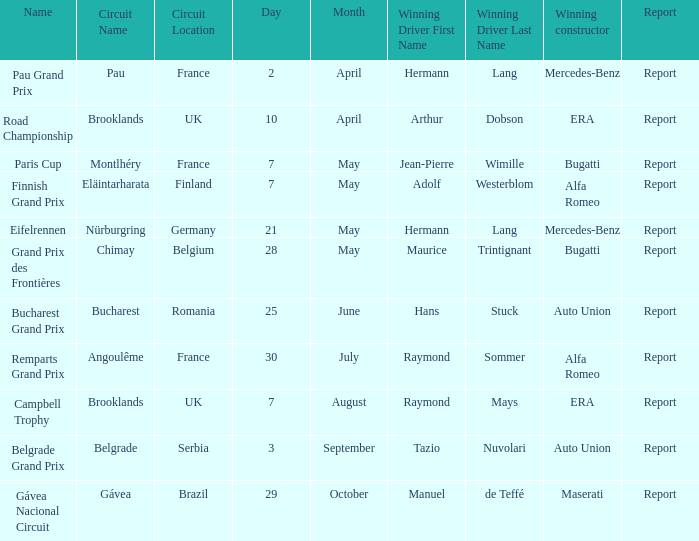Tell me the winning constructor for the paris cup Bugatti. Give me the full table as a dictionary. {'header': ['Name', 'Circuit Name', 'Circuit Location', 'Day', 'Month', 'Winning Driver First Name', 'Winning Driver Last Name', 'Winning constructor', 'Report'], 'rows': [['Pau Grand Prix', 'Pau', 'France', '2', 'April', 'Hermann', 'Lang', 'Mercedes-Benz', 'Report'], ['Road Championship', 'Brooklands', 'UK', '10', 'April', 'Arthur', 'Dobson', 'ERA', 'Report'], ['Paris Cup', 'Montlhéry', 'France', '7', 'May', 'Jean-Pierre', 'Wimille', 'Bugatti', 'Report'], ['Finnish Grand Prix', 'Eläintarharata', 'Finland', '7', 'May', 'Adolf', 'Westerblom', 'Alfa Romeo', 'Report'], ['Eifelrennen', 'Nürburgring', 'Germany', '21', 'May', 'Hermann', 'Lang', 'Mercedes-Benz', 'Report'], ['Grand Prix des Frontières', 'Chimay', 'Belgium', '28', 'May', 'Maurice', 'Trintignant', 'Bugatti', 'Report'], ['Bucharest Grand Prix', 'Bucharest', 'Romania', '25', 'June', 'Hans', 'Stuck', 'Auto Union', 'Report'], ['Remparts Grand Prix', 'Angoulême', 'France', '30', 'July', 'Raymond', 'Sommer', 'Alfa Romeo', 'Report'], ['Campbell Trophy', 'Brooklands', 'UK', '7', 'August', 'Raymond', 'Mays', 'ERA', 'Report'], ['Belgrade Grand Prix', 'Belgrade', 'Serbia', '3', 'September', 'Tazio', 'Nuvolari', 'Auto Union', 'Report'], ['Gávea Nacional Circuit', 'Gávea', 'Brazil', '29', 'October', 'Manuel', 'de Teffé', 'Maserati', 'Report']]} 